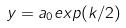Convert formula to latex. <formula><loc_0><loc_0><loc_500><loc_500>y = a _ { 0 } e x p ( k / 2 )</formula> 